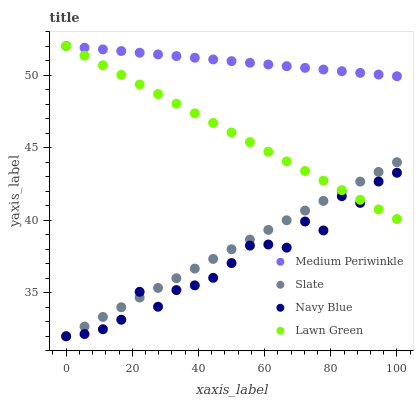Does Navy Blue have the minimum area under the curve?
Answer yes or no. Yes. Does Medium Periwinkle have the maximum area under the curve?
Answer yes or no. Yes. Does Slate have the minimum area under the curve?
Answer yes or no. No. Does Slate have the maximum area under the curve?
Answer yes or no. No. Is Medium Periwinkle the smoothest?
Answer yes or no. Yes. Is Navy Blue the roughest?
Answer yes or no. Yes. Is Slate the smoothest?
Answer yes or no. No. Is Slate the roughest?
Answer yes or no. No. Does Navy Blue have the lowest value?
Answer yes or no. Yes. Does Medium Periwinkle have the lowest value?
Answer yes or no. No. Does Lawn Green have the highest value?
Answer yes or no. Yes. Does Slate have the highest value?
Answer yes or no. No. Is Navy Blue less than Medium Periwinkle?
Answer yes or no. Yes. Is Medium Periwinkle greater than Navy Blue?
Answer yes or no. Yes. Does Lawn Green intersect Medium Periwinkle?
Answer yes or no. Yes. Is Lawn Green less than Medium Periwinkle?
Answer yes or no. No. Is Lawn Green greater than Medium Periwinkle?
Answer yes or no. No. Does Navy Blue intersect Medium Periwinkle?
Answer yes or no. No. 